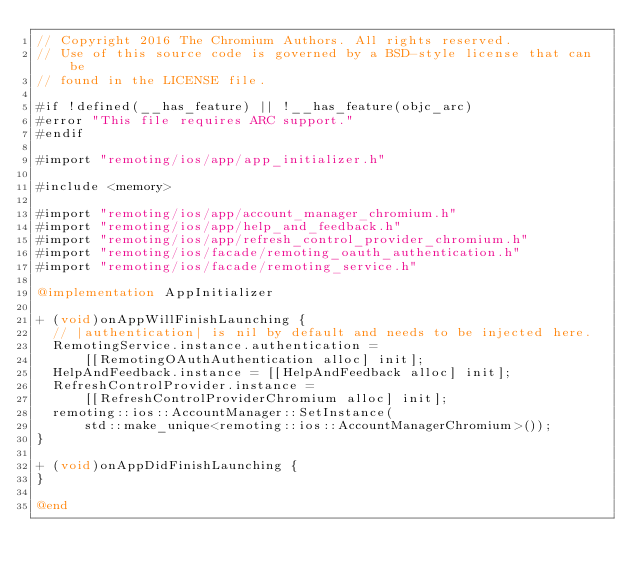<code> <loc_0><loc_0><loc_500><loc_500><_ObjectiveC_>// Copyright 2016 The Chromium Authors. All rights reserved.
// Use of this source code is governed by a BSD-style license that can be
// found in the LICENSE file.

#if !defined(__has_feature) || !__has_feature(objc_arc)
#error "This file requires ARC support."
#endif

#import "remoting/ios/app/app_initializer.h"

#include <memory>

#import "remoting/ios/app/account_manager_chromium.h"
#import "remoting/ios/app/help_and_feedback.h"
#import "remoting/ios/app/refresh_control_provider_chromium.h"
#import "remoting/ios/facade/remoting_oauth_authentication.h"
#import "remoting/ios/facade/remoting_service.h"

@implementation AppInitializer

+ (void)onAppWillFinishLaunching {
  // |authentication| is nil by default and needs to be injected here.
  RemotingService.instance.authentication =
      [[RemotingOAuthAuthentication alloc] init];
  HelpAndFeedback.instance = [[HelpAndFeedback alloc] init];
  RefreshControlProvider.instance =
      [[RefreshControlProviderChromium alloc] init];
  remoting::ios::AccountManager::SetInstance(
      std::make_unique<remoting::ios::AccountManagerChromium>());
}

+ (void)onAppDidFinishLaunching {
}

@end
</code> 